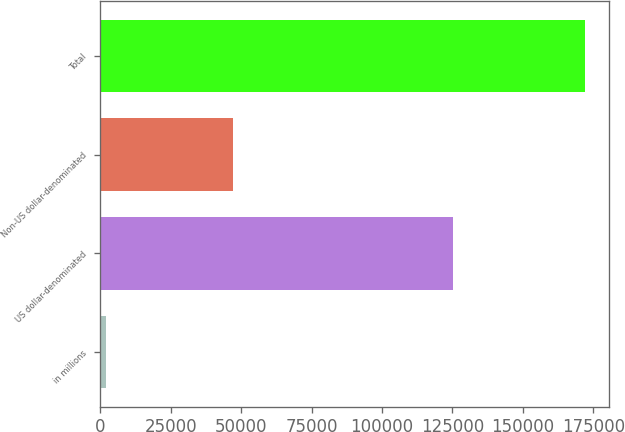Convert chart. <chart><loc_0><loc_0><loc_500><loc_500><bar_chart><fcel>in millions<fcel>US dollar-denominated<fcel>Non-US dollar-denominated<fcel>Total<nl><fcel>2012<fcel>125111<fcel>46984<fcel>172095<nl></chart> 